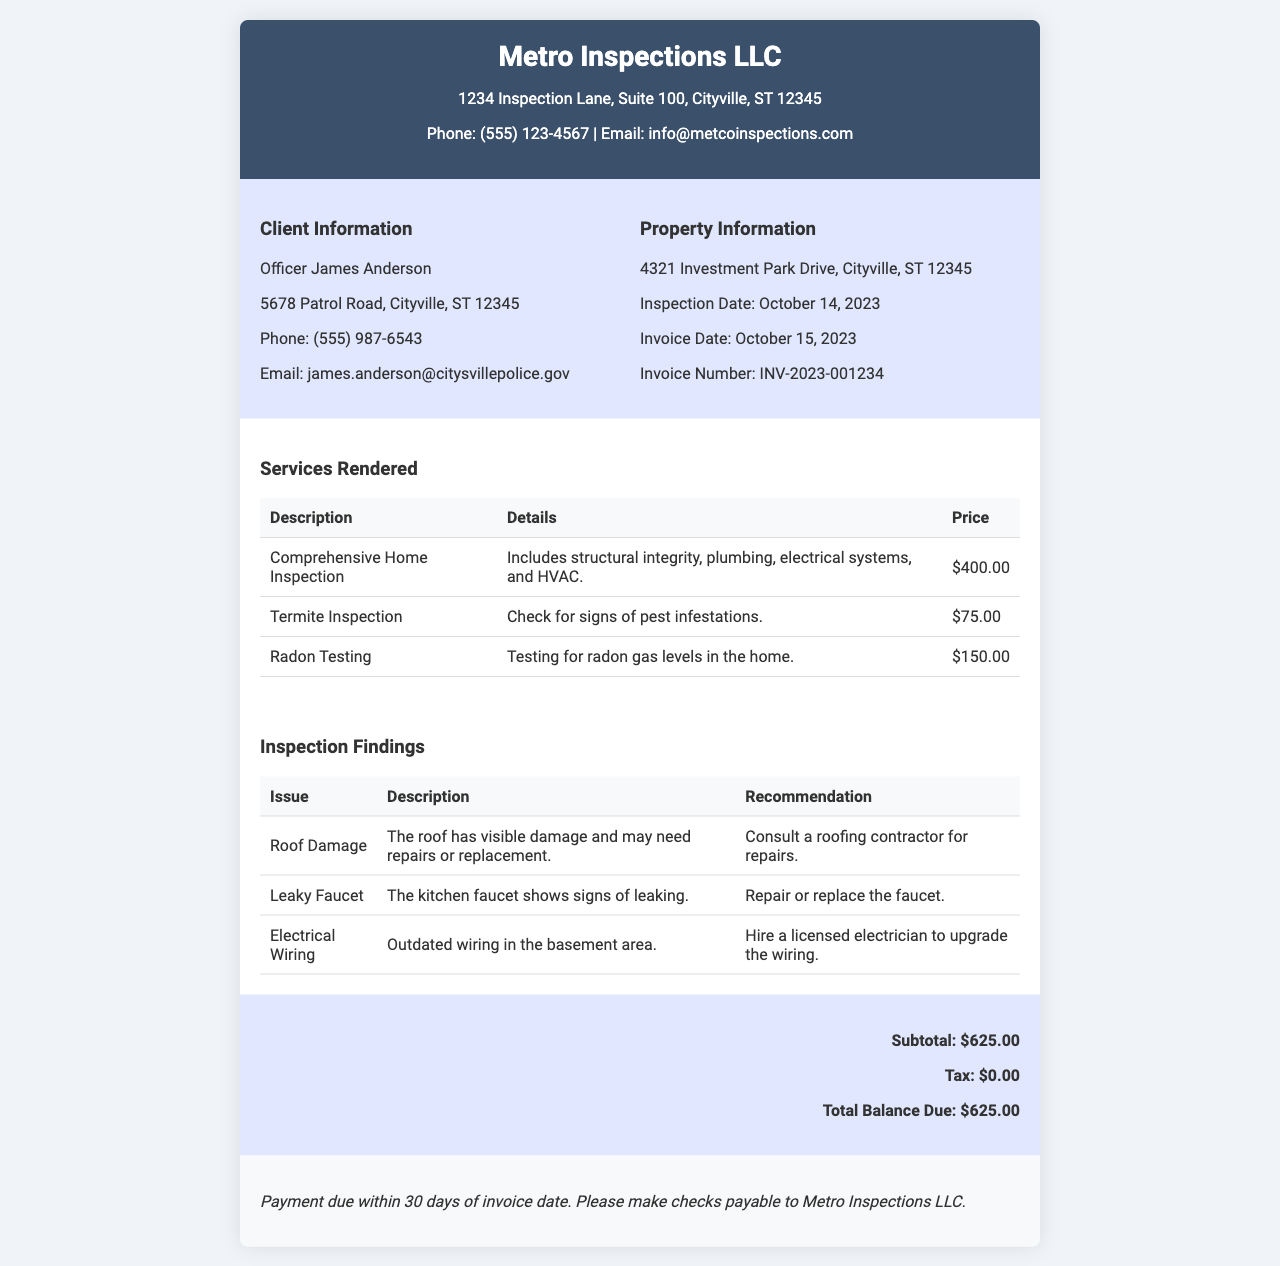What is the invoice number? The invoice number is found in the document to identify the specific transaction, which is INV-2023-001234.
Answer: INV-2023-001234 Who is the client? The client information section identifies the individual receiving the services, which is Officer James Anderson.
Answer: Officer James Anderson What is the date of the inspection? The inspection date is provided to indicate when the service took place, which is October 14, 2023.
Answer: October 14, 2023 What is the subtotal amount? The subtotal is specified to show the total before tax, which is $625.00.
Answer: $625.00 How many services were rendered? The document lists the individual services provided during the inspection, which are three.
Answer: Three What type of inspection was conducted? The document specifies the main type of service provided, which is a Comprehensive Home Inspection.
Answer: Comprehensive Home Inspection What is the recommendation for the leaky faucet? The findings section includes recommendations for issues found during the inspection, for the leaky faucet it advises to repair or replace it.
Answer: Repair or replace the faucet What is the total balance due? The total balance due is indicated at the end of the invoice, which is $625.00.
Answer: $625.00 What should payment be made out to? The payment terms state who the check should be made payable to, which is Metro Inspections LLC.
Answer: Metro Inspections LLC 